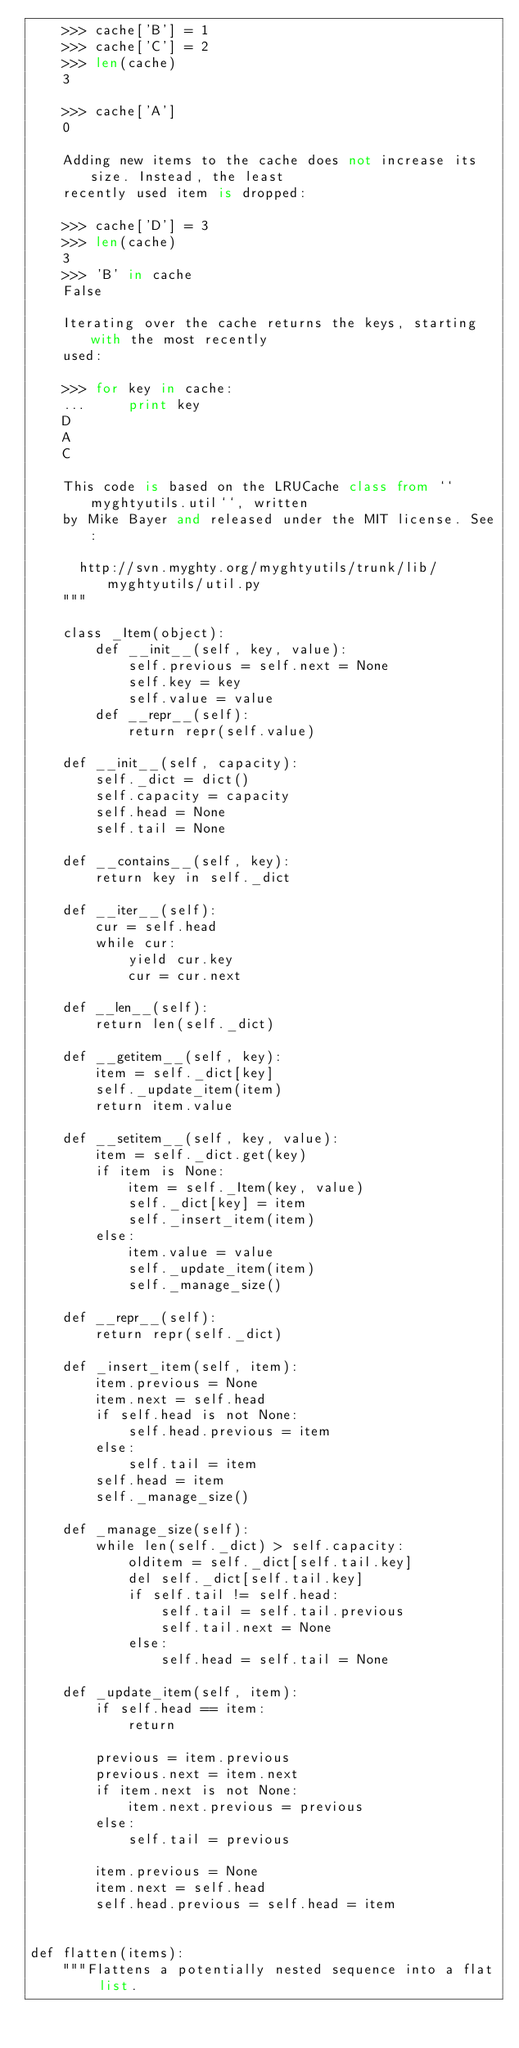<code> <loc_0><loc_0><loc_500><loc_500><_Python_>    >>> cache['B'] = 1
    >>> cache['C'] = 2
    >>> len(cache)
    3
    
    >>> cache['A']
    0
    
    Adding new items to the cache does not increase its size. Instead, the least
    recently used item is dropped:
    
    >>> cache['D'] = 3
    >>> len(cache)
    3
    >>> 'B' in cache
    False
    
    Iterating over the cache returns the keys, starting with the most recently
    used:
    
    >>> for key in cache:
    ...     print key
    D
    A
    C

    This code is based on the LRUCache class from ``myghtyutils.util``, written
    by Mike Bayer and released under the MIT license. See:

      http://svn.myghty.org/myghtyutils/trunk/lib/myghtyutils/util.py
    """

    class _Item(object):
        def __init__(self, key, value):
            self.previous = self.next = None
            self.key = key
            self.value = value
        def __repr__(self):
            return repr(self.value)

    def __init__(self, capacity):
        self._dict = dict()
        self.capacity = capacity
        self.head = None
        self.tail = None

    def __contains__(self, key):
        return key in self._dict

    def __iter__(self):
        cur = self.head
        while cur:
            yield cur.key
            cur = cur.next

    def __len__(self):
        return len(self._dict)

    def __getitem__(self, key):
        item = self._dict[key]
        self._update_item(item)
        return item.value

    def __setitem__(self, key, value):
        item = self._dict.get(key)
        if item is None:
            item = self._Item(key, value)
            self._dict[key] = item
            self._insert_item(item)
        else:
            item.value = value
            self._update_item(item)
            self._manage_size()

    def __repr__(self):
        return repr(self._dict)

    def _insert_item(self, item):
        item.previous = None
        item.next = self.head
        if self.head is not None:
            self.head.previous = item
        else:
            self.tail = item
        self.head = item
        self._manage_size()

    def _manage_size(self):
        while len(self._dict) > self.capacity:
            olditem = self._dict[self.tail.key]
            del self._dict[self.tail.key]
            if self.tail != self.head:
                self.tail = self.tail.previous
                self.tail.next = None
            else:
                self.head = self.tail = None

    def _update_item(self, item):
        if self.head == item:
            return

        previous = item.previous
        previous.next = item.next
        if item.next is not None:
            item.next.previous = previous
        else:
            self.tail = previous

        item.previous = None
        item.next = self.head
        self.head.previous = self.head = item


def flatten(items):
    """Flattens a potentially nested sequence into a flat list.
    </code> 